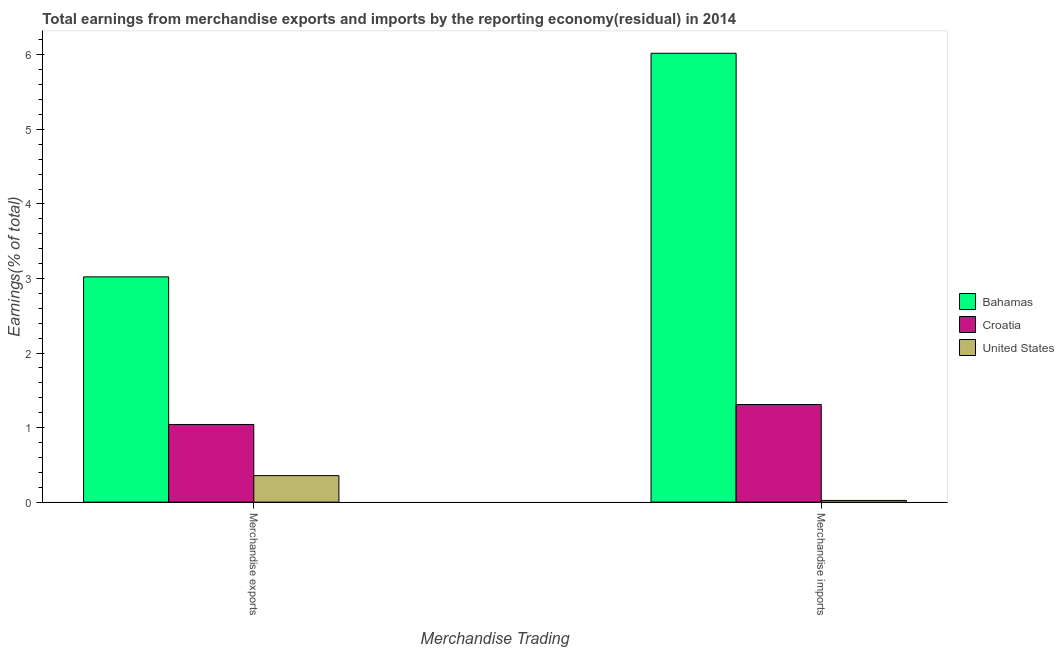How many groups of bars are there?
Give a very brief answer. 2. Are the number of bars per tick equal to the number of legend labels?
Your answer should be compact. Yes. How many bars are there on the 1st tick from the left?
Make the answer very short. 3. How many bars are there on the 1st tick from the right?
Provide a succinct answer. 3. What is the label of the 1st group of bars from the left?
Give a very brief answer. Merchandise exports. What is the earnings from merchandise imports in Bahamas?
Make the answer very short. 6.02. Across all countries, what is the maximum earnings from merchandise imports?
Keep it short and to the point. 6.02. Across all countries, what is the minimum earnings from merchandise imports?
Offer a terse response. 0.02. In which country was the earnings from merchandise imports maximum?
Your response must be concise. Bahamas. In which country was the earnings from merchandise exports minimum?
Your answer should be very brief. United States. What is the total earnings from merchandise imports in the graph?
Make the answer very short. 7.35. What is the difference between the earnings from merchandise exports in United States and that in Bahamas?
Offer a very short reply. -2.67. What is the difference between the earnings from merchandise imports in Bahamas and the earnings from merchandise exports in Croatia?
Give a very brief answer. 4.98. What is the average earnings from merchandise imports per country?
Your response must be concise. 2.45. What is the difference between the earnings from merchandise exports and earnings from merchandise imports in United States?
Make the answer very short. 0.33. In how many countries, is the earnings from merchandise imports greater than 4.2 %?
Offer a very short reply. 1. What is the ratio of the earnings from merchandise exports in United States to that in Croatia?
Ensure brevity in your answer.  0.34. What does the 2nd bar from the left in Merchandise exports represents?
Provide a short and direct response. Croatia. How many countries are there in the graph?
Give a very brief answer. 3. Does the graph contain any zero values?
Offer a very short reply. No. Does the graph contain grids?
Provide a succinct answer. No. Where does the legend appear in the graph?
Offer a very short reply. Center right. How many legend labels are there?
Provide a succinct answer. 3. What is the title of the graph?
Your response must be concise. Total earnings from merchandise exports and imports by the reporting economy(residual) in 2014. What is the label or title of the X-axis?
Offer a terse response. Merchandise Trading. What is the label or title of the Y-axis?
Your response must be concise. Earnings(% of total). What is the Earnings(% of total) in Bahamas in Merchandise exports?
Keep it short and to the point. 3.02. What is the Earnings(% of total) of Croatia in Merchandise exports?
Make the answer very short. 1.04. What is the Earnings(% of total) of United States in Merchandise exports?
Keep it short and to the point. 0.36. What is the Earnings(% of total) in Bahamas in Merchandise imports?
Ensure brevity in your answer.  6.02. What is the Earnings(% of total) of Croatia in Merchandise imports?
Keep it short and to the point. 1.31. What is the Earnings(% of total) in United States in Merchandise imports?
Your response must be concise. 0.02. Across all Merchandise Trading, what is the maximum Earnings(% of total) in Bahamas?
Give a very brief answer. 6.02. Across all Merchandise Trading, what is the maximum Earnings(% of total) of Croatia?
Your response must be concise. 1.31. Across all Merchandise Trading, what is the maximum Earnings(% of total) of United States?
Make the answer very short. 0.36. Across all Merchandise Trading, what is the minimum Earnings(% of total) in Bahamas?
Keep it short and to the point. 3.02. Across all Merchandise Trading, what is the minimum Earnings(% of total) of Croatia?
Ensure brevity in your answer.  1.04. Across all Merchandise Trading, what is the minimum Earnings(% of total) in United States?
Your answer should be very brief. 0.02. What is the total Earnings(% of total) of Bahamas in the graph?
Your response must be concise. 9.04. What is the total Earnings(% of total) in Croatia in the graph?
Your answer should be compact. 2.35. What is the total Earnings(% of total) in United States in the graph?
Provide a succinct answer. 0.38. What is the difference between the Earnings(% of total) of Bahamas in Merchandise exports and that in Merchandise imports?
Provide a short and direct response. -3. What is the difference between the Earnings(% of total) of Croatia in Merchandise exports and that in Merchandise imports?
Give a very brief answer. -0.27. What is the difference between the Earnings(% of total) in United States in Merchandise exports and that in Merchandise imports?
Keep it short and to the point. 0.33. What is the difference between the Earnings(% of total) in Bahamas in Merchandise exports and the Earnings(% of total) in Croatia in Merchandise imports?
Offer a very short reply. 1.71. What is the difference between the Earnings(% of total) in Bahamas in Merchandise exports and the Earnings(% of total) in United States in Merchandise imports?
Provide a succinct answer. 3. What is the difference between the Earnings(% of total) of Croatia in Merchandise exports and the Earnings(% of total) of United States in Merchandise imports?
Keep it short and to the point. 1.02. What is the average Earnings(% of total) of Bahamas per Merchandise Trading?
Provide a short and direct response. 4.52. What is the average Earnings(% of total) in Croatia per Merchandise Trading?
Offer a very short reply. 1.18. What is the average Earnings(% of total) in United States per Merchandise Trading?
Give a very brief answer. 0.19. What is the difference between the Earnings(% of total) in Bahamas and Earnings(% of total) in Croatia in Merchandise exports?
Give a very brief answer. 1.98. What is the difference between the Earnings(% of total) in Bahamas and Earnings(% of total) in United States in Merchandise exports?
Provide a short and direct response. 2.67. What is the difference between the Earnings(% of total) of Croatia and Earnings(% of total) of United States in Merchandise exports?
Make the answer very short. 0.69. What is the difference between the Earnings(% of total) of Bahamas and Earnings(% of total) of Croatia in Merchandise imports?
Offer a very short reply. 4.71. What is the difference between the Earnings(% of total) in Bahamas and Earnings(% of total) in United States in Merchandise imports?
Your response must be concise. 6. What is the difference between the Earnings(% of total) in Croatia and Earnings(% of total) in United States in Merchandise imports?
Offer a terse response. 1.29. What is the ratio of the Earnings(% of total) in Bahamas in Merchandise exports to that in Merchandise imports?
Your response must be concise. 0.5. What is the ratio of the Earnings(% of total) of Croatia in Merchandise exports to that in Merchandise imports?
Provide a succinct answer. 0.8. What is the ratio of the Earnings(% of total) in United States in Merchandise exports to that in Merchandise imports?
Give a very brief answer. 15.58. What is the difference between the highest and the second highest Earnings(% of total) of Bahamas?
Provide a succinct answer. 3. What is the difference between the highest and the second highest Earnings(% of total) in Croatia?
Keep it short and to the point. 0.27. What is the difference between the highest and the second highest Earnings(% of total) in United States?
Provide a short and direct response. 0.33. What is the difference between the highest and the lowest Earnings(% of total) in Bahamas?
Offer a terse response. 3. What is the difference between the highest and the lowest Earnings(% of total) in Croatia?
Provide a short and direct response. 0.27. What is the difference between the highest and the lowest Earnings(% of total) of United States?
Keep it short and to the point. 0.33. 